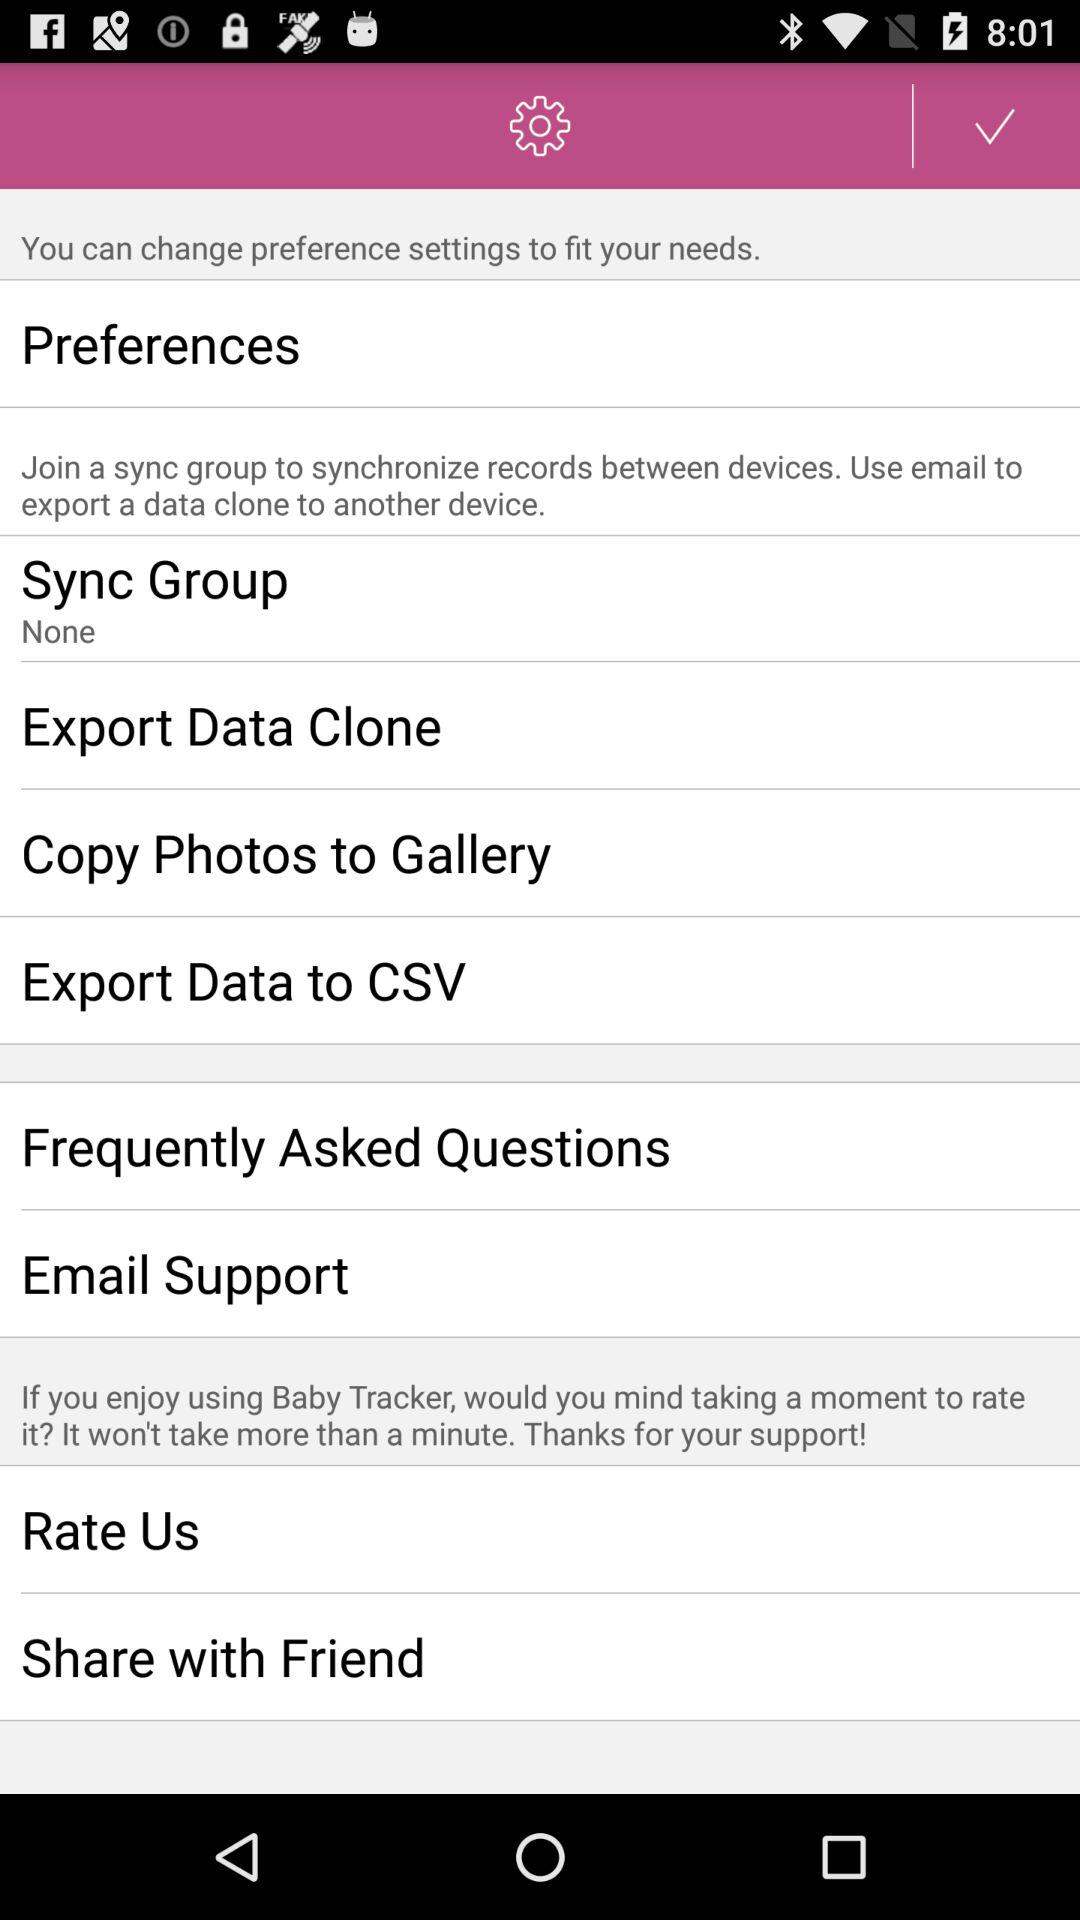What's the status of "Sync Group"? The status is "None". 